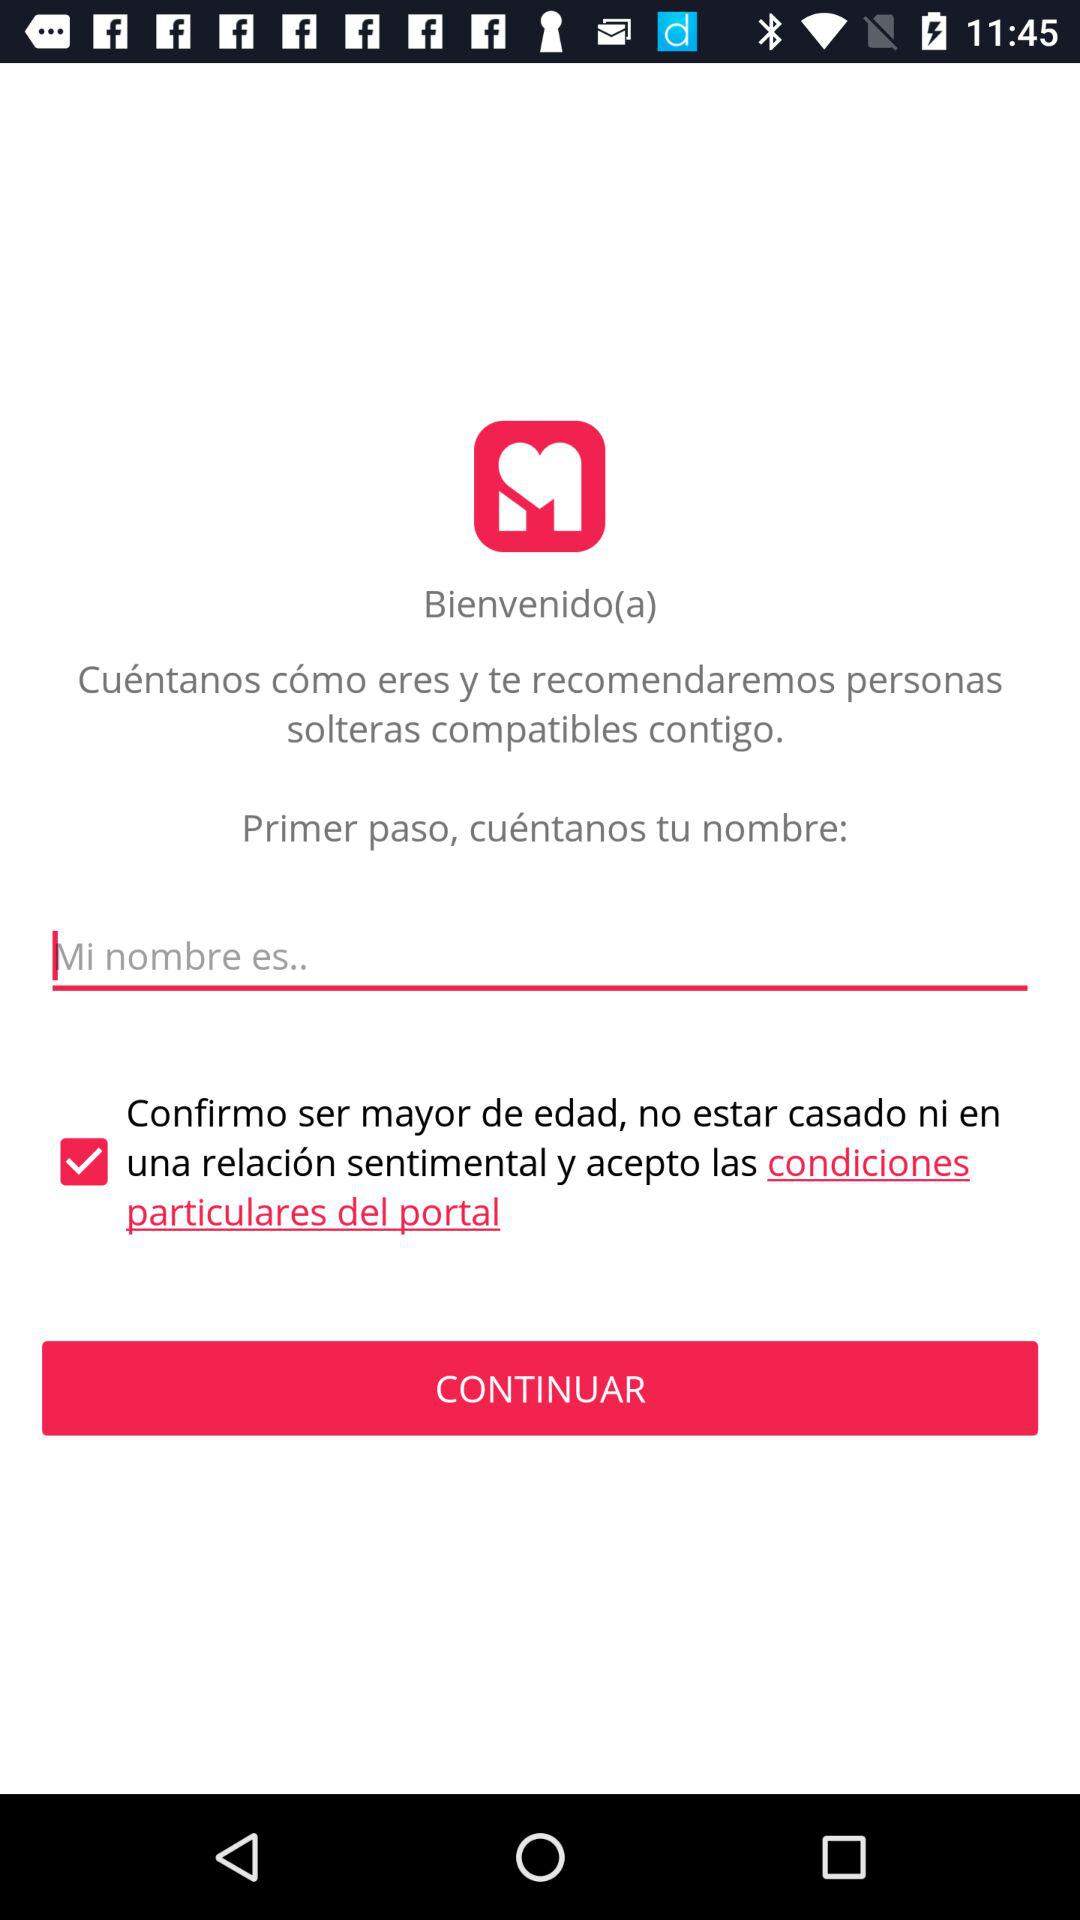How many check boxes are there on this screen?
Answer the question using a single word or phrase. 1 